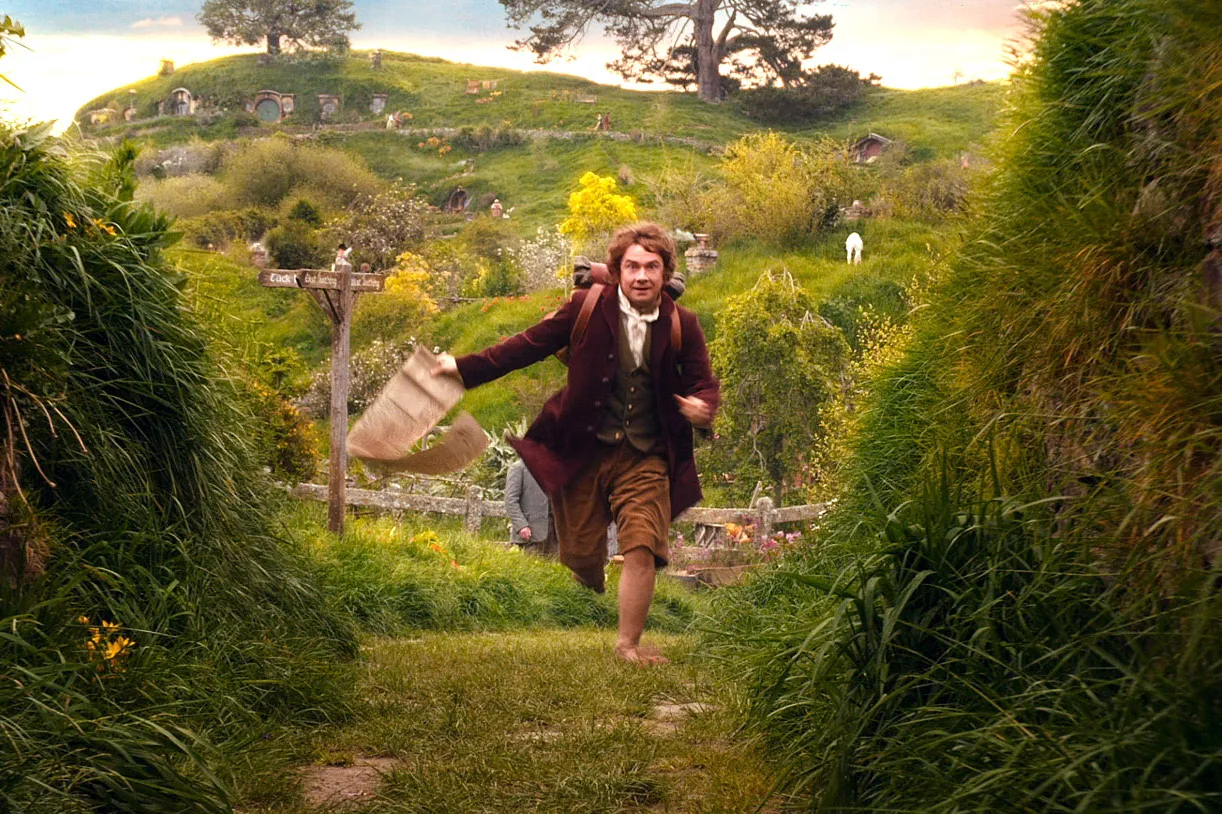What are the key elements in this picture? In this captivating image, we see a character mid-stride, running through the picturesque and lush green landscape of The Shire. The landscape is dotted with charming hobbit holes that are nestled into the rolling hills. The character, dressed in a brown jacket, a white shirt, and brown trousers, carries a beige bag and appears to be in a hurry. A prominent signpost that reads 'Bag End' indicates the location as the residence of the hobbit Bilbo Baggins. The image beautifully captures a moment of urgency and adventure, set against the tranquil and enchanting backdrop of The Shire. 